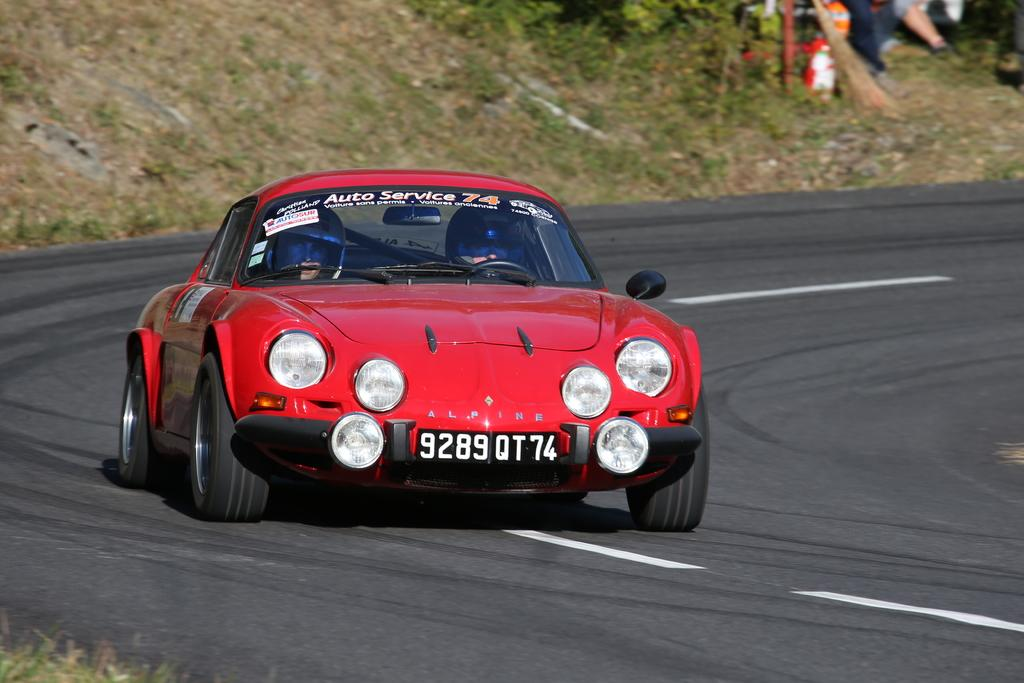What type of landscape can be seen in the background of the image? There is a dried grassland area in the background. What else is present in the background? There are plants and a broomstick visible in the background. What is the main subject of the image? The main subject of the image is a car on the road. How many people are inside the car? Two persons are inside the car. What are the persons in the car wearing? The persons in the car are wearing helmets. What type of bath can be seen in the image? There is no bath present in the image. What is the profit of the persons in the car? The image does not provide information about the profit of the persons in the car. 